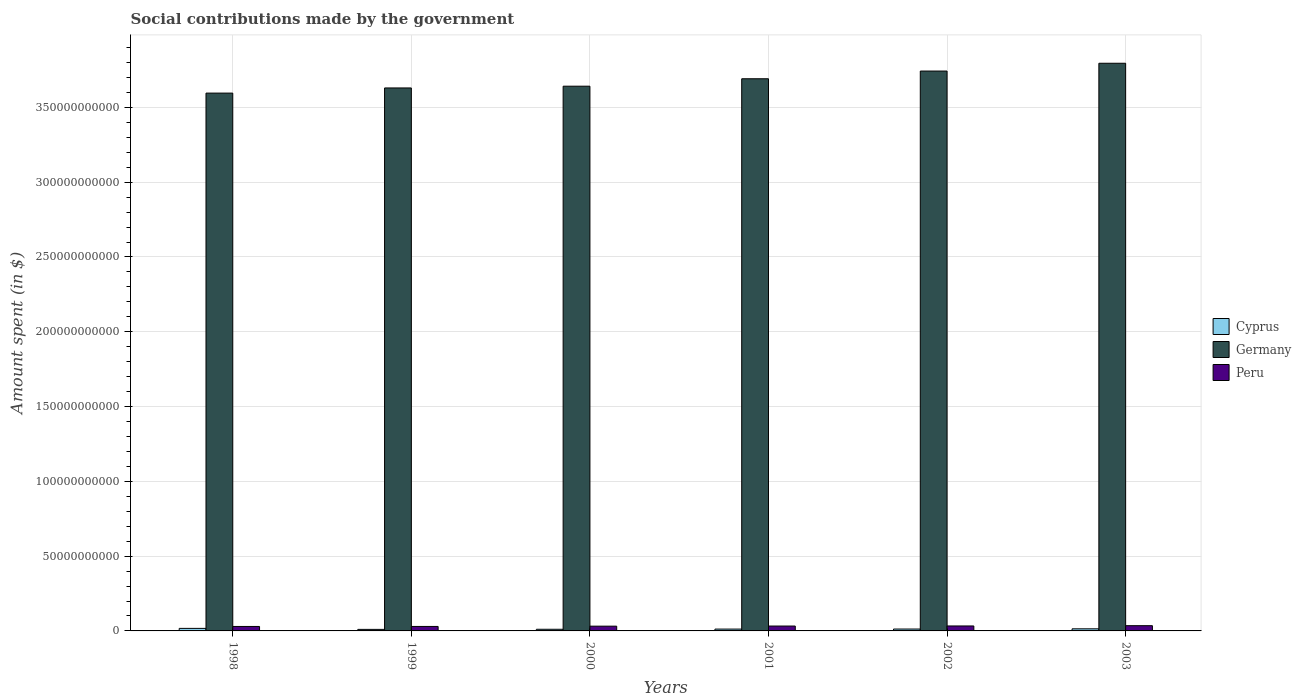How many different coloured bars are there?
Provide a succinct answer. 3. How many groups of bars are there?
Offer a very short reply. 6. Are the number of bars per tick equal to the number of legend labels?
Provide a short and direct response. Yes. What is the amount spent on social contributions in Cyprus in 2003?
Keep it short and to the point. 1.40e+09. Across all years, what is the maximum amount spent on social contributions in Cyprus?
Provide a short and direct response. 1.70e+09. Across all years, what is the minimum amount spent on social contributions in Peru?
Your answer should be very brief. 2.99e+09. In which year was the amount spent on social contributions in Cyprus maximum?
Provide a succinct answer. 1998. In which year was the amount spent on social contributions in Cyprus minimum?
Ensure brevity in your answer.  1999. What is the total amount spent on social contributions in Germany in the graph?
Provide a short and direct response. 2.21e+12. What is the difference between the amount spent on social contributions in Germany in 1998 and that in 2002?
Provide a succinct answer. -1.47e+1. What is the difference between the amount spent on social contributions in Cyprus in 1998 and the amount spent on social contributions in Peru in 2002?
Your answer should be very brief. -1.62e+09. What is the average amount spent on social contributions in Cyprus per year?
Keep it short and to the point. 1.29e+09. In the year 1999, what is the difference between the amount spent on social contributions in Germany and amount spent on social contributions in Cyprus?
Provide a succinct answer. 3.62e+11. What is the ratio of the amount spent on social contributions in Peru in 1998 to that in 2001?
Your response must be concise. 0.92. Is the amount spent on social contributions in Peru in 2001 less than that in 2002?
Offer a terse response. Yes. What is the difference between the highest and the second highest amount spent on social contributions in Peru?
Your answer should be compact. 1.84e+08. What is the difference between the highest and the lowest amount spent on social contributions in Peru?
Your answer should be very brief. 5.18e+08. Is the sum of the amount spent on social contributions in Peru in 1999 and 2000 greater than the maximum amount spent on social contributions in Germany across all years?
Provide a short and direct response. No. What does the 1st bar from the left in 2003 represents?
Your answer should be very brief. Cyprus. What does the 3rd bar from the right in 2002 represents?
Your answer should be compact. Cyprus. How many bars are there?
Provide a short and direct response. 18. Are all the bars in the graph horizontal?
Ensure brevity in your answer.  No. What is the difference between two consecutive major ticks on the Y-axis?
Make the answer very short. 5.00e+1. Are the values on the major ticks of Y-axis written in scientific E-notation?
Your answer should be compact. No. Where does the legend appear in the graph?
Make the answer very short. Center right. What is the title of the graph?
Offer a very short reply. Social contributions made by the government. Does "Belgium" appear as one of the legend labels in the graph?
Keep it short and to the point. No. What is the label or title of the X-axis?
Ensure brevity in your answer.  Years. What is the label or title of the Y-axis?
Offer a terse response. Amount spent (in $). What is the Amount spent (in $) in Cyprus in 1998?
Provide a short and direct response. 1.70e+09. What is the Amount spent (in $) of Germany in 1998?
Keep it short and to the point. 3.60e+11. What is the Amount spent (in $) in Peru in 1998?
Give a very brief answer. 2.99e+09. What is the Amount spent (in $) in Cyprus in 1999?
Provide a short and direct response. 1.03e+09. What is the Amount spent (in $) in Germany in 1999?
Keep it short and to the point. 3.63e+11. What is the Amount spent (in $) in Peru in 1999?
Give a very brief answer. 3.00e+09. What is the Amount spent (in $) in Cyprus in 2000?
Your answer should be compact. 1.10e+09. What is the Amount spent (in $) in Germany in 2000?
Your answer should be compact. 3.64e+11. What is the Amount spent (in $) in Peru in 2000?
Make the answer very short. 3.19e+09. What is the Amount spent (in $) of Cyprus in 2001?
Your response must be concise. 1.23e+09. What is the Amount spent (in $) in Germany in 2001?
Keep it short and to the point. 3.69e+11. What is the Amount spent (in $) of Peru in 2001?
Provide a short and direct response. 3.26e+09. What is the Amount spent (in $) in Cyprus in 2002?
Your answer should be very brief. 1.26e+09. What is the Amount spent (in $) in Germany in 2002?
Provide a short and direct response. 3.74e+11. What is the Amount spent (in $) of Peru in 2002?
Your answer should be compact. 3.32e+09. What is the Amount spent (in $) in Cyprus in 2003?
Give a very brief answer. 1.40e+09. What is the Amount spent (in $) of Germany in 2003?
Your answer should be compact. 3.80e+11. What is the Amount spent (in $) of Peru in 2003?
Your answer should be very brief. 3.50e+09. Across all years, what is the maximum Amount spent (in $) in Cyprus?
Ensure brevity in your answer.  1.70e+09. Across all years, what is the maximum Amount spent (in $) of Germany?
Provide a succinct answer. 3.80e+11. Across all years, what is the maximum Amount spent (in $) in Peru?
Your answer should be compact. 3.50e+09. Across all years, what is the minimum Amount spent (in $) in Cyprus?
Give a very brief answer. 1.03e+09. Across all years, what is the minimum Amount spent (in $) in Germany?
Offer a very short reply. 3.60e+11. Across all years, what is the minimum Amount spent (in $) in Peru?
Give a very brief answer. 2.99e+09. What is the total Amount spent (in $) in Cyprus in the graph?
Provide a succinct answer. 7.72e+09. What is the total Amount spent (in $) of Germany in the graph?
Offer a very short reply. 2.21e+12. What is the total Amount spent (in $) in Peru in the graph?
Keep it short and to the point. 1.93e+1. What is the difference between the Amount spent (in $) of Cyprus in 1998 and that in 1999?
Make the answer very short. 6.69e+08. What is the difference between the Amount spent (in $) of Germany in 1998 and that in 1999?
Give a very brief answer. -3.44e+09. What is the difference between the Amount spent (in $) in Peru in 1998 and that in 1999?
Your answer should be compact. -1.16e+07. What is the difference between the Amount spent (in $) in Cyprus in 1998 and that in 2000?
Provide a short and direct response. 5.91e+08. What is the difference between the Amount spent (in $) in Germany in 1998 and that in 2000?
Provide a short and direct response. -4.61e+09. What is the difference between the Amount spent (in $) in Peru in 1998 and that in 2000?
Give a very brief answer. -2.00e+08. What is the difference between the Amount spent (in $) of Cyprus in 1998 and that in 2001?
Offer a very short reply. 4.65e+08. What is the difference between the Amount spent (in $) of Germany in 1998 and that in 2001?
Provide a short and direct response. -9.59e+09. What is the difference between the Amount spent (in $) in Peru in 1998 and that in 2001?
Give a very brief answer. -2.75e+08. What is the difference between the Amount spent (in $) of Cyprus in 1998 and that in 2002?
Your answer should be very brief. 4.38e+08. What is the difference between the Amount spent (in $) in Germany in 1998 and that in 2002?
Give a very brief answer. -1.47e+1. What is the difference between the Amount spent (in $) in Peru in 1998 and that in 2002?
Provide a succinct answer. -3.35e+08. What is the difference between the Amount spent (in $) in Cyprus in 1998 and that in 2003?
Your response must be concise. 2.93e+08. What is the difference between the Amount spent (in $) in Germany in 1998 and that in 2003?
Provide a short and direct response. -2.00e+1. What is the difference between the Amount spent (in $) in Peru in 1998 and that in 2003?
Keep it short and to the point. -5.18e+08. What is the difference between the Amount spent (in $) in Cyprus in 1999 and that in 2000?
Your answer should be compact. -7.84e+07. What is the difference between the Amount spent (in $) of Germany in 1999 and that in 2000?
Provide a short and direct response. -1.17e+09. What is the difference between the Amount spent (in $) of Peru in 1999 and that in 2000?
Your answer should be compact. -1.88e+08. What is the difference between the Amount spent (in $) in Cyprus in 1999 and that in 2001?
Give a very brief answer. -2.04e+08. What is the difference between the Amount spent (in $) of Germany in 1999 and that in 2001?
Provide a succinct answer. -6.15e+09. What is the difference between the Amount spent (in $) of Peru in 1999 and that in 2001?
Your response must be concise. -2.63e+08. What is the difference between the Amount spent (in $) of Cyprus in 1999 and that in 2002?
Your response must be concise. -2.31e+08. What is the difference between the Amount spent (in $) in Germany in 1999 and that in 2002?
Offer a very short reply. -1.13e+1. What is the difference between the Amount spent (in $) in Peru in 1999 and that in 2002?
Make the answer very short. -3.23e+08. What is the difference between the Amount spent (in $) of Cyprus in 1999 and that in 2003?
Keep it short and to the point. -3.77e+08. What is the difference between the Amount spent (in $) in Germany in 1999 and that in 2003?
Make the answer very short. -1.65e+1. What is the difference between the Amount spent (in $) of Peru in 1999 and that in 2003?
Provide a short and direct response. -5.07e+08. What is the difference between the Amount spent (in $) in Cyprus in 2000 and that in 2001?
Your response must be concise. -1.26e+08. What is the difference between the Amount spent (in $) in Germany in 2000 and that in 2001?
Your answer should be compact. -4.98e+09. What is the difference between the Amount spent (in $) of Peru in 2000 and that in 2001?
Your answer should be compact. -7.48e+07. What is the difference between the Amount spent (in $) of Cyprus in 2000 and that in 2002?
Offer a terse response. -1.53e+08. What is the difference between the Amount spent (in $) of Germany in 2000 and that in 2002?
Give a very brief answer. -1.01e+1. What is the difference between the Amount spent (in $) in Peru in 2000 and that in 2002?
Offer a terse response. -1.35e+08. What is the difference between the Amount spent (in $) of Cyprus in 2000 and that in 2003?
Make the answer very short. -2.98e+08. What is the difference between the Amount spent (in $) in Germany in 2000 and that in 2003?
Keep it short and to the point. -1.53e+1. What is the difference between the Amount spent (in $) in Peru in 2000 and that in 2003?
Give a very brief answer. -3.18e+08. What is the difference between the Amount spent (in $) in Cyprus in 2001 and that in 2002?
Keep it short and to the point. -2.68e+07. What is the difference between the Amount spent (in $) in Germany in 2001 and that in 2002?
Provide a succinct answer. -5.15e+09. What is the difference between the Amount spent (in $) in Peru in 2001 and that in 2002?
Offer a very short reply. -5.99e+07. What is the difference between the Amount spent (in $) in Cyprus in 2001 and that in 2003?
Ensure brevity in your answer.  -1.72e+08. What is the difference between the Amount spent (in $) in Germany in 2001 and that in 2003?
Offer a terse response. -1.04e+1. What is the difference between the Amount spent (in $) of Peru in 2001 and that in 2003?
Offer a very short reply. -2.44e+08. What is the difference between the Amount spent (in $) of Cyprus in 2002 and that in 2003?
Provide a short and direct response. -1.46e+08. What is the difference between the Amount spent (in $) in Germany in 2002 and that in 2003?
Your response must be concise. -5.21e+09. What is the difference between the Amount spent (in $) of Peru in 2002 and that in 2003?
Your answer should be compact. -1.84e+08. What is the difference between the Amount spent (in $) in Cyprus in 1998 and the Amount spent (in $) in Germany in 1999?
Provide a succinct answer. -3.61e+11. What is the difference between the Amount spent (in $) in Cyprus in 1998 and the Amount spent (in $) in Peru in 1999?
Give a very brief answer. -1.30e+09. What is the difference between the Amount spent (in $) of Germany in 1998 and the Amount spent (in $) of Peru in 1999?
Keep it short and to the point. 3.57e+11. What is the difference between the Amount spent (in $) in Cyprus in 1998 and the Amount spent (in $) in Germany in 2000?
Provide a short and direct response. -3.62e+11. What is the difference between the Amount spent (in $) of Cyprus in 1998 and the Amount spent (in $) of Peru in 2000?
Provide a short and direct response. -1.49e+09. What is the difference between the Amount spent (in $) in Germany in 1998 and the Amount spent (in $) in Peru in 2000?
Give a very brief answer. 3.56e+11. What is the difference between the Amount spent (in $) of Cyprus in 1998 and the Amount spent (in $) of Germany in 2001?
Provide a succinct answer. -3.67e+11. What is the difference between the Amount spent (in $) in Cyprus in 1998 and the Amount spent (in $) in Peru in 2001?
Offer a very short reply. -1.56e+09. What is the difference between the Amount spent (in $) of Germany in 1998 and the Amount spent (in $) of Peru in 2001?
Your answer should be compact. 3.56e+11. What is the difference between the Amount spent (in $) of Cyprus in 1998 and the Amount spent (in $) of Germany in 2002?
Provide a succinct answer. -3.73e+11. What is the difference between the Amount spent (in $) of Cyprus in 1998 and the Amount spent (in $) of Peru in 2002?
Ensure brevity in your answer.  -1.62e+09. What is the difference between the Amount spent (in $) in Germany in 1998 and the Amount spent (in $) in Peru in 2002?
Provide a short and direct response. 3.56e+11. What is the difference between the Amount spent (in $) in Cyprus in 1998 and the Amount spent (in $) in Germany in 2003?
Provide a succinct answer. -3.78e+11. What is the difference between the Amount spent (in $) in Cyprus in 1998 and the Amount spent (in $) in Peru in 2003?
Your answer should be very brief. -1.81e+09. What is the difference between the Amount spent (in $) of Germany in 1998 and the Amount spent (in $) of Peru in 2003?
Provide a short and direct response. 3.56e+11. What is the difference between the Amount spent (in $) of Cyprus in 1999 and the Amount spent (in $) of Germany in 2000?
Your answer should be compact. -3.63e+11. What is the difference between the Amount spent (in $) in Cyprus in 1999 and the Amount spent (in $) in Peru in 2000?
Give a very brief answer. -2.16e+09. What is the difference between the Amount spent (in $) of Germany in 1999 and the Amount spent (in $) of Peru in 2000?
Offer a terse response. 3.60e+11. What is the difference between the Amount spent (in $) of Cyprus in 1999 and the Amount spent (in $) of Germany in 2001?
Your response must be concise. -3.68e+11. What is the difference between the Amount spent (in $) in Cyprus in 1999 and the Amount spent (in $) in Peru in 2001?
Give a very brief answer. -2.23e+09. What is the difference between the Amount spent (in $) of Germany in 1999 and the Amount spent (in $) of Peru in 2001?
Keep it short and to the point. 3.60e+11. What is the difference between the Amount spent (in $) of Cyprus in 1999 and the Amount spent (in $) of Germany in 2002?
Ensure brevity in your answer.  -3.73e+11. What is the difference between the Amount spent (in $) in Cyprus in 1999 and the Amount spent (in $) in Peru in 2002?
Your answer should be compact. -2.29e+09. What is the difference between the Amount spent (in $) in Germany in 1999 and the Amount spent (in $) in Peru in 2002?
Offer a terse response. 3.60e+11. What is the difference between the Amount spent (in $) in Cyprus in 1999 and the Amount spent (in $) in Germany in 2003?
Your response must be concise. -3.79e+11. What is the difference between the Amount spent (in $) in Cyprus in 1999 and the Amount spent (in $) in Peru in 2003?
Make the answer very short. -2.48e+09. What is the difference between the Amount spent (in $) of Germany in 1999 and the Amount spent (in $) of Peru in 2003?
Your answer should be very brief. 3.60e+11. What is the difference between the Amount spent (in $) in Cyprus in 2000 and the Amount spent (in $) in Germany in 2001?
Your response must be concise. -3.68e+11. What is the difference between the Amount spent (in $) in Cyprus in 2000 and the Amount spent (in $) in Peru in 2001?
Make the answer very short. -2.16e+09. What is the difference between the Amount spent (in $) in Germany in 2000 and the Amount spent (in $) in Peru in 2001?
Give a very brief answer. 3.61e+11. What is the difference between the Amount spent (in $) in Cyprus in 2000 and the Amount spent (in $) in Germany in 2002?
Ensure brevity in your answer.  -3.73e+11. What is the difference between the Amount spent (in $) of Cyprus in 2000 and the Amount spent (in $) of Peru in 2002?
Give a very brief answer. -2.22e+09. What is the difference between the Amount spent (in $) of Germany in 2000 and the Amount spent (in $) of Peru in 2002?
Make the answer very short. 3.61e+11. What is the difference between the Amount spent (in $) in Cyprus in 2000 and the Amount spent (in $) in Germany in 2003?
Provide a short and direct response. -3.78e+11. What is the difference between the Amount spent (in $) of Cyprus in 2000 and the Amount spent (in $) of Peru in 2003?
Your response must be concise. -2.40e+09. What is the difference between the Amount spent (in $) in Germany in 2000 and the Amount spent (in $) in Peru in 2003?
Provide a short and direct response. 3.61e+11. What is the difference between the Amount spent (in $) in Cyprus in 2001 and the Amount spent (in $) in Germany in 2002?
Give a very brief answer. -3.73e+11. What is the difference between the Amount spent (in $) in Cyprus in 2001 and the Amount spent (in $) in Peru in 2002?
Your answer should be compact. -2.09e+09. What is the difference between the Amount spent (in $) of Germany in 2001 and the Amount spent (in $) of Peru in 2002?
Your answer should be compact. 3.66e+11. What is the difference between the Amount spent (in $) in Cyprus in 2001 and the Amount spent (in $) in Germany in 2003?
Give a very brief answer. -3.78e+11. What is the difference between the Amount spent (in $) in Cyprus in 2001 and the Amount spent (in $) in Peru in 2003?
Your answer should be very brief. -2.27e+09. What is the difference between the Amount spent (in $) in Germany in 2001 and the Amount spent (in $) in Peru in 2003?
Offer a very short reply. 3.66e+11. What is the difference between the Amount spent (in $) in Cyprus in 2002 and the Amount spent (in $) in Germany in 2003?
Provide a succinct answer. -3.78e+11. What is the difference between the Amount spent (in $) of Cyprus in 2002 and the Amount spent (in $) of Peru in 2003?
Make the answer very short. -2.25e+09. What is the difference between the Amount spent (in $) in Germany in 2002 and the Amount spent (in $) in Peru in 2003?
Your answer should be compact. 3.71e+11. What is the average Amount spent (in $) in Cyprus per year?
Provide a short and direct response. 1.29e+09. What is the average Amount spent (in $) in Germany per year?
Give a very brief answer. 3.68e+11. What is the average Amount spent (in $) of Peru per year?
Ensure brevity in your answer.  3.21e+09. In the year 1998, what is the difference between the Amount spent (in $) in Cyprus and Amount spent (in $) in Germany?
Offer a very short reply. -3.58e+11. In the year 1998, what is the difference between the Amount spent (in $) in Cyprus and Amount spent (in $) in Peru?
Offer a terse response. -1.29e+09. In the year 1998, what is the difference between the Amount spent (in $) of Germany and Amount spent (in $) of Peru?
Give a very brief answer. 3.57e+11. In the year 1999, what is the difference between the Amount spent (in $) in Cyprus and Amount spent (in $) in Germany?
Provide a short and direct response. -3.62e+11. In the year 1999, what is the difference between the Amount spent (in $) in Cyprus and Amount spent (in $) in Peru?
Provide a succinct answer. -1.97e+09. In the year 1999, what is the difference between the Amount spent (in $) in Germany and Amount spent (in $) in Peru?
Offer a very short reply. 3.60e+11. In the year 2000, what is the difference between the Amount spent (in $) in Cyprus and Amount spent (in $) in Germany?
Your answer should be compact. -3.63e+11. In the year 2000, what is the difference between the Amount spent (in $) in Cyprus and Amount spent (in $) in Peru?
Provide a short and direct response. -2.08e+09. In the year 2000, what is the difference between the Amount spent (in $) of Germany and Amount spent (in $) of Peru?
Make the answer very short. 3.61e+11. In the year 2001, what is the difference between the Amount spent (in $) in Cyprus and Amount spent (in $) in Germany?
Ensure brevity in your answer.  -3.68e+11. In the year 2001, what is the difference between the Amount spent (in $) in Cyprus and Amount spent (in $) in Peru?
Your response must be concise. -2.03e+09. In the year 2001, what is the difference between the Amount spent (in $) in Germany and Amount spent (in $) in Peru?
Provide a succinct answer. 3.66e+11. In the year 2002, what is the difference between the Amount spent (in $) in Cyprus and Amount spent (in $) in Germany?
Your answer should be compact. -3.73e+11. In the year 2002, what is the difference between the Amount spent (in $) of Cyprus and Amount spent (in $) of Peru?
Ensure brevity in your answer.  -2.06e+09. In the year 2002, what is the difference between the Amount spent (in $) in Germany and Amount spent (in $) in Peru?
Make the answer very short. 3.71e+11. In the year 2003, what is the difference between the Amount spent (in $) in Cyprus and Amount spent (in $) in Germany?
Provide a succinct answer. -3.78e+11. In the year 2003, what is the difference between the Amount spent (in $) of Cyprus and Amount spent (in $) of Peru?
Ensure brevity in your answer.  -2.10e+09. In the year 2003, what is the difference between the Amount spent (in $) in Germany and Amount spent (in $) in Peru?
Offer a very short reply. 3.76e+11. What is the ratio of the Amount spent (in $) in Cyprus in 1998 to that in 1999?
Your response must be concise. 1.65. What is the ratio of the Amount spent (in $) of Peru in 1998 to that in 1999?
Keep it short and to the point. 1. What is the ratio of the Amount spent (in $) of Cyprus in 1998 to that in 2000?
Offer a terse response. 1.53. What is the ratio of the Amount spent (in $) in Germany in 1998 to that in 2000?
Your answer should be compact. 0.99. What is the ratio of the Amount spent (in $) of Peru in 1998 to that in 2000?
Provide a short and direct response. 0.94. What is the ratio of the Amount spent (in $) in Cyprus in 1998 to that in 2001?
Your answer should be compact. 1.38. What is the ratio of the Amount spent (in $) of Germany in 1998 to that in 2001?
Provide a succinct answer. 0.97. What is the ratio of the Amount spent (in $) in Peru in 1998 to that in 2001?
Ensure brevity in your answer.  0.92. What is the ratio of the Amount spent (in $) in Cyprus in 1998 to that in 2002?
Your answer should be compact. 1.35. What is the ratio of the Amount spent (in $) of Germany in 1998 to that in 2002?
Your answer should be compact. 0.96. What is the ratio of the Amount spent (in $) of Peru in 1998 to that in 2002?
Make the answer very short. 0.9. What is the ratio of the Amount spent (in $) of Cyprus in 1998 to that in 2003?
Offer a terse response. 1.21. What is the ratio of the Amount spent (in $) in Germany in 1998 to that in 2003?
Provide a succinct answer. 0.95. What is the ratio of the Amount spent (in $) of Peru in 1998 to that in 2003?
Offer a very short reply. 0.85. What is the ratio of the Amount spent (in $) in Cyprus in 1999 to that in 2000?
Provide a succinct answer. 0.93. What is the ratio of the Amount spent (in $) of Peru in 1999 to that in 2000?
Your response must be concise. 0.94. What is the ratio of the Amount spent (in $) of Cyprus in 1999 to that in 2001?
Offer a very short reply. 0.83. What is the ratio of the Amount spent (in $) of Germany in 1999 to that in 2001?
Provide a succinct answer. 0.98. What is the ratio of the Amount spent (in $) in Peru in 1999 to that in 2001?
Offer a very short reply. 0.92. What is the ratio of the Amount spent (in $) of Cyprus in 1999 to that in 2002?
Your answer should be compact. 0.82. What is the ratio of the Amount spent (in $) in Germany in 1999 to that in 2002?
Provide a succinct answer. 0.97. What is the ratio of the Amount spent (in $) of Peru in 1999 to that in 2002?
Give a very brief answer. 0.9. What is the ratio of the Amount spent (in $) in Cyprus in 1999 to that in 2003?
Your answer should be very brief. 0.73. What is the ratio of the Amount spent (in $) in Germany in 1999 to that in 2003?
Give a very brief answer. 0.96. What is the ratio of the Amount spent (in $) in Peru in 1999 to that in 2003?
Offer a very short reply. 0.86. What is the ratio of the Amount spent (in $) of Cyprus in 2000 to that in 2001?
Ensure brevity in your answer.  0.9. What is the ratio of the Amount spent (in $) of Germany in 2000 to that in 2001?
Your answer should be very brief. 0.99. What is the ratio of the Amount spent (in $) of Peru in 2000 to that in 2001?
Provide a succinct answer. 0.98. What is the ratio of the Amount spent (in $) of Cyprus in 2000 to that in 2002?
Your answer should be very brief. 0.88. What is the ratio of the Amount spent (in $) of Germany in 2000 to that in 2002?
Give a very brief answer. 0.97. What is the ratio of the Amount spent (in $) of Peru in 2000 to that in 2002?
Offer a terse response. 0.96. What is the ratio of the Amount spent (in $) in Cyprus in 2000 to that in 2003?
Your answer should be compact. 0.79. What is the ratio of the Amount spent (in $) in Germany in 2000 to that in 2003?
Make the answer very short. 0.96. What is the ratio of the Amount spent (in $) of Peru in 2000 to that in 2003?
Keep it short and to the point. 0.91. What is the ratio of the Amount spent (in $) of Cyprus in 2001 to that in 2002?
Provide a succinct answer. 0.98. What is the ratio of the Amount spent (in $) of Germany in 2001 to that in 2002?
Your answer should be compact. 0.99. What is the ratio of the Amount spent (in $) of Peru in 2001 to that in 2002?
Your answer should be compact. 0.98. What is the ratio of the Amount spent (in $) of Cyprus in 2001 to that in 2003?
Provide a short and direct response. 0.88. What is the ratio of the Amount spent (in $) in Germany in 2001 to that in 2003?
Offer a terse response. 0.97. What is the ratio of the Amount spent (in $) of Peru in 2001 to that in 2003?
Make the answer very short. 0.93. What is the ratio of the Amount spent (in $) in Cyprus in 2002 to that in 2003?
Give a very brief answer. 0.9. What is the ratio of the Amount spent (in $) in Germany in 2002 to that in 2003?
Your answer should be very brief. 0.99. What is the ratio of the Amount spent (in $) of Peru in 2002 to that in 2003?
Make the answer very short. 0.95. What is the difference between the highest and the second highest Amount spent (in $) in Cyprus?
Your response must be concise. 2.93e+08. What is the difference between the highest and the second highest Amount spent (in $) of Germany?
Keep it short and to the point. 5.21e+09. What is the difference between the highest and the second highest Amount spent (in $) of Peru?
Make the answer very short. 1.84e+08. What is the difference between the highest and the lowest Amount spent (in $) in Cyprus?
Keep it short and to the point. 6.69e+08. What is the difference between the highest and the lowest Amount spent (in $) of Germany?
Your answer should be very brief. 2.00e+1. What is the difference between the highest and the lowest Amount spent (in $) of Peru?
Provide a succinct answer. 5.18e+08. 